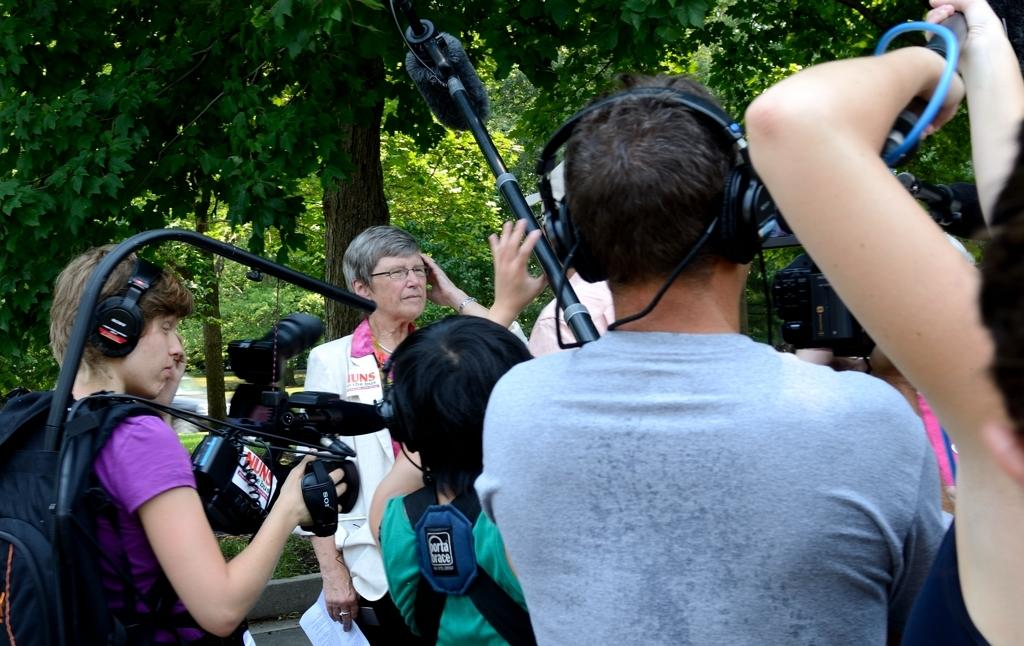What are the people in the image doing? The people in the image are standing. Can you describe what one person is wearing? One person is wearing a bag. What is one person holding in the image? One person is holding a camera. What is another person holding in the image? Another person is holding papers. What can be seen in the background of the image? There are trees visible in the background of the image. Is there a game of soccer happening in the image? No, there is no game of soccer visible in the image. Is there a rainstorm occurring in the image? No, there is no rainstorm visible in the image. 